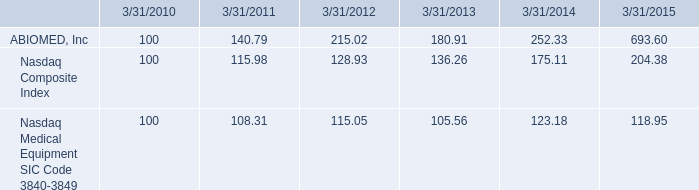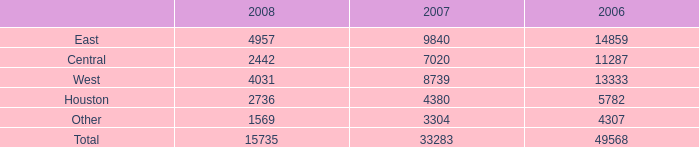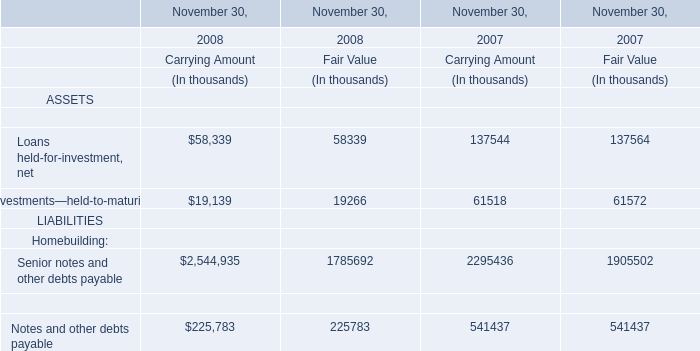What's the average of the West in the years where Investments—held-to-maturity for Financial services for Carrying Amount is greater than 0? 
Computations: ((4031 + 8739) / 2)
Answer: 6385.0. 